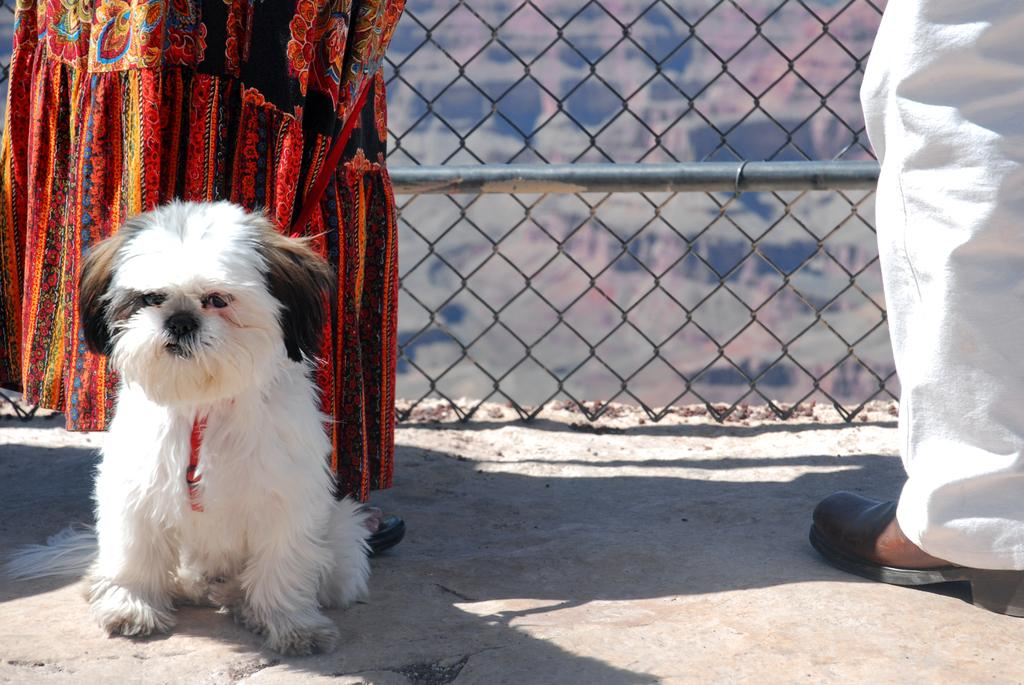How many people are present in the image? There are two people in the image. What other living creature is in the image? There is a dog in the image. Can you describe the appearance of the dog? The dog has white, black, and cream colors. What can be seen in the background of the image? There is a metal rod and a fence in the background of the image. What type of cloth is being used to promote the growth of the dog in the image? There is no cloth or growth promotion mentioned or depicted in the image; it features two people and a dog with specific colors. 